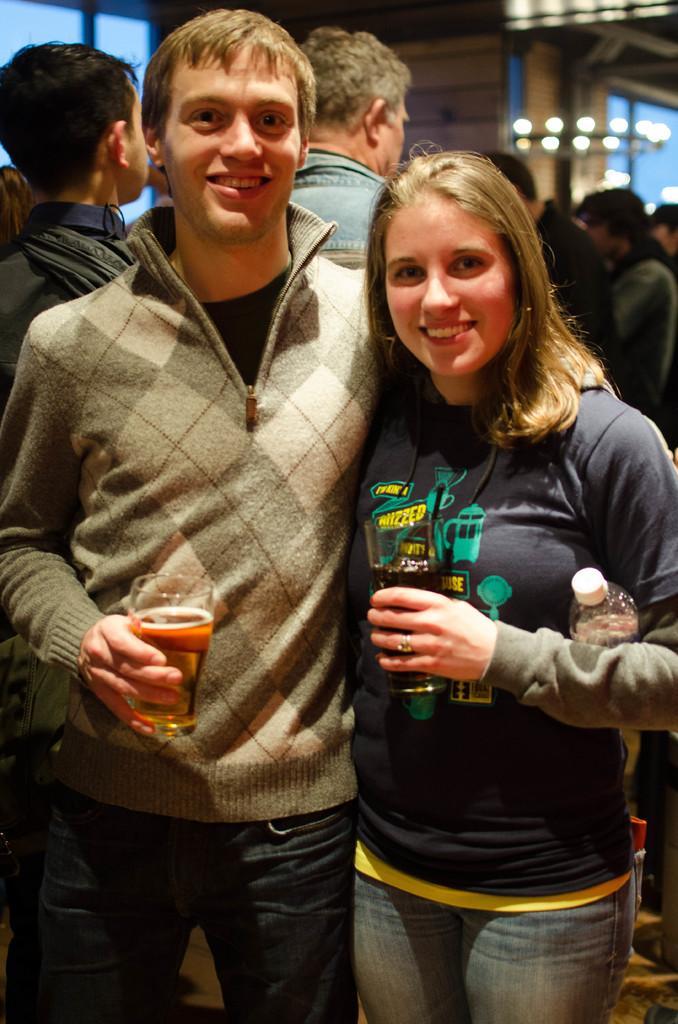Could you give a brief overview of what you see in this image? In front of the picture, we see the man and the women are standing. They are holding the glasses containing the liquids in their hands. She is even holding the water bottle. Both of them are smiling and they might be posing for the photo. Behind them, we see people are standing. In the background, we see the windows, a wall and the lights. This picture is blurred in the background. 